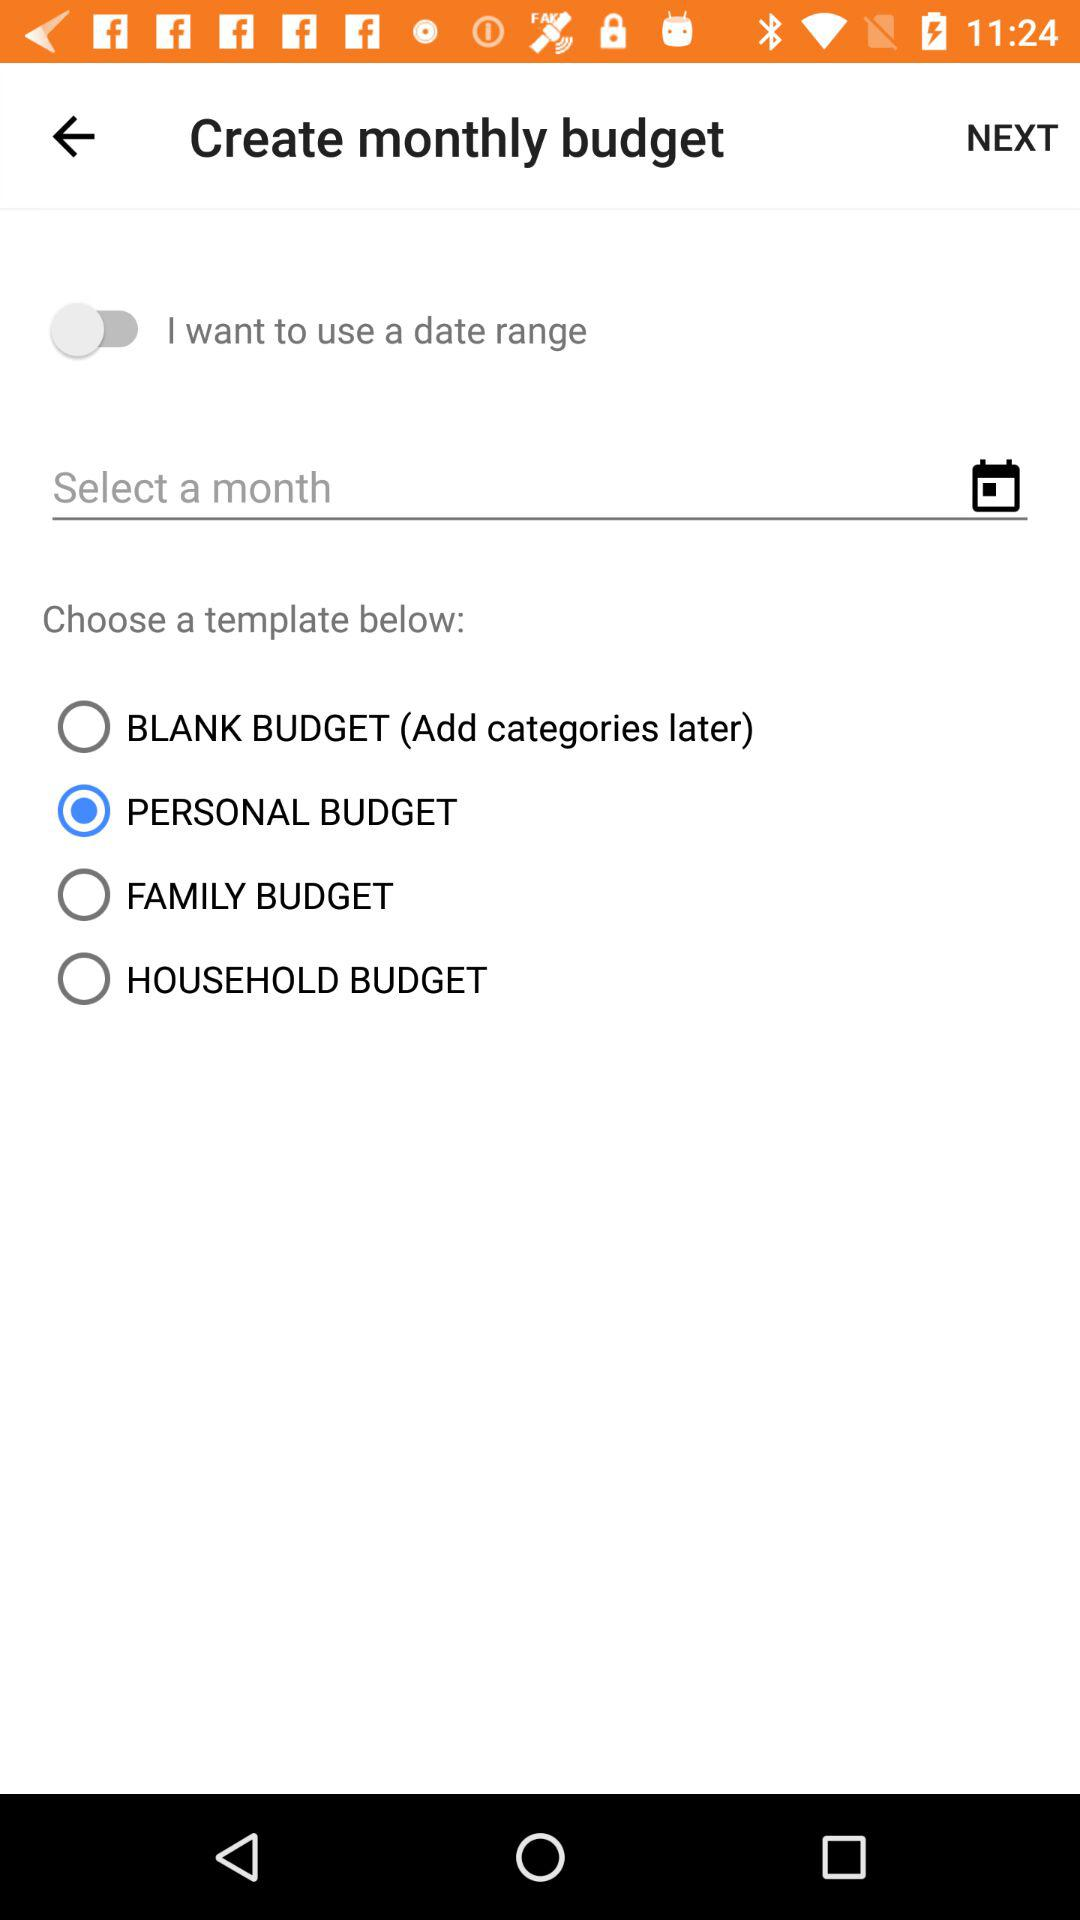Which template was selected? The selected template was "PERSONAL BUDGET". 